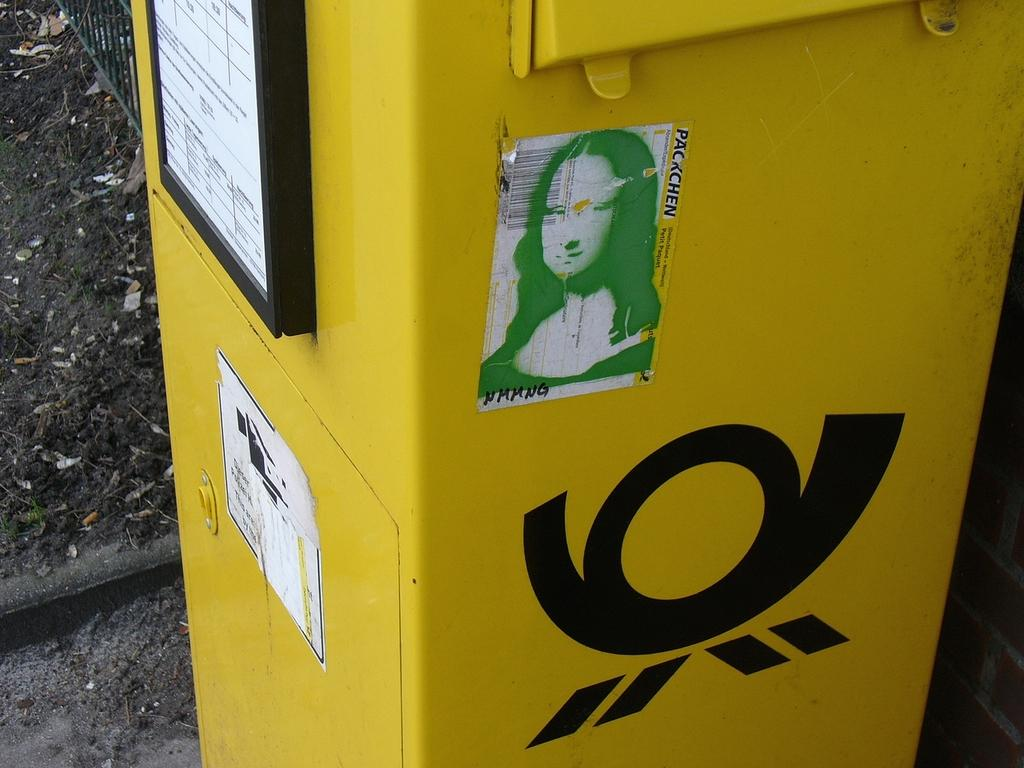Provide a one-sentence caption for the provided image. A yellow receptacle in the outdoors with a Packchen sticker on it. 